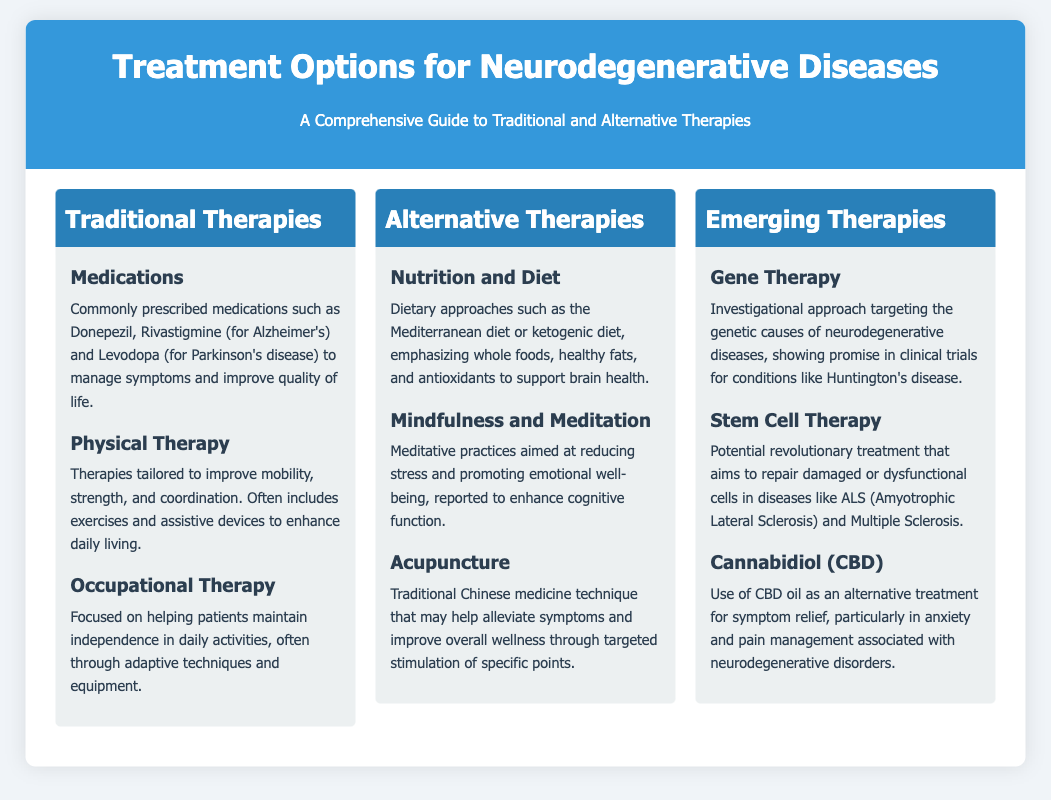What are the three categories of therapies listed? The document lists Traditional Therapies, Alternative Therapies, and Emerging Therapies as the three categories.
Answer: Traditional Therapies, Alternative Therapies, Emerging Therapies What medication is commonly prescribed for Alzheimer's? The document mentions Donepezil and Rivastigmine as commonly prescribed medications for Alzheimer's disease.
Answer: Donepezil, Rivastigmine What therapy focuses on daily activity independence? Occupational Therapy is focused on helping patients maintain independence in daily activities.
Answer: Occupational Therapy What dietary approach is mentioned for brain health? The Mediterranean diet or ketogenic diet is emphasized in the document as supportive of brain health.
Answer: Mediterranean diet, ketogenic diet What alternative therapy involves meditative practices? Mindfulness and Meditation are the alternative therapies that involve meditative practices aimed at reducing stress.
Answer: Mindfulness and Meditation What is a potential revolutionary treatment for ALS? Stem Cell Therapy is described as a potential revolutionary treatment for Amyotrophic Lateral Sclerosis (ALS).
Answer: Stem Cell Therapy Which therapy targets genetic causes of diseases? The investigational approach known as Gene Therapy targets the genetic causes of neurodegenerative diseases.
Answer: Gene Therapy What does CBD oil aim to relieve in neurodegenerative disorders? CBD oil is used primarily for symptom relief, particularly in anxiety and pain management.
Answer: Anxiety and pain management 